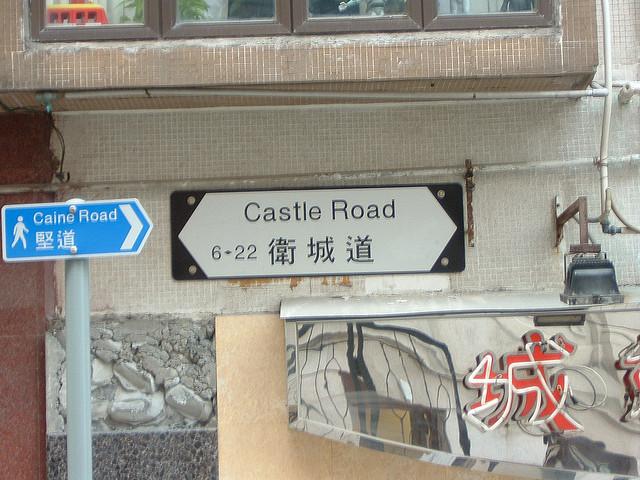Is Caine Road within walking distance?
Quick response, please. Yes. What color is the street sign?
Short answer required. Blue. Is this an American street?
Concise answer only. No. 